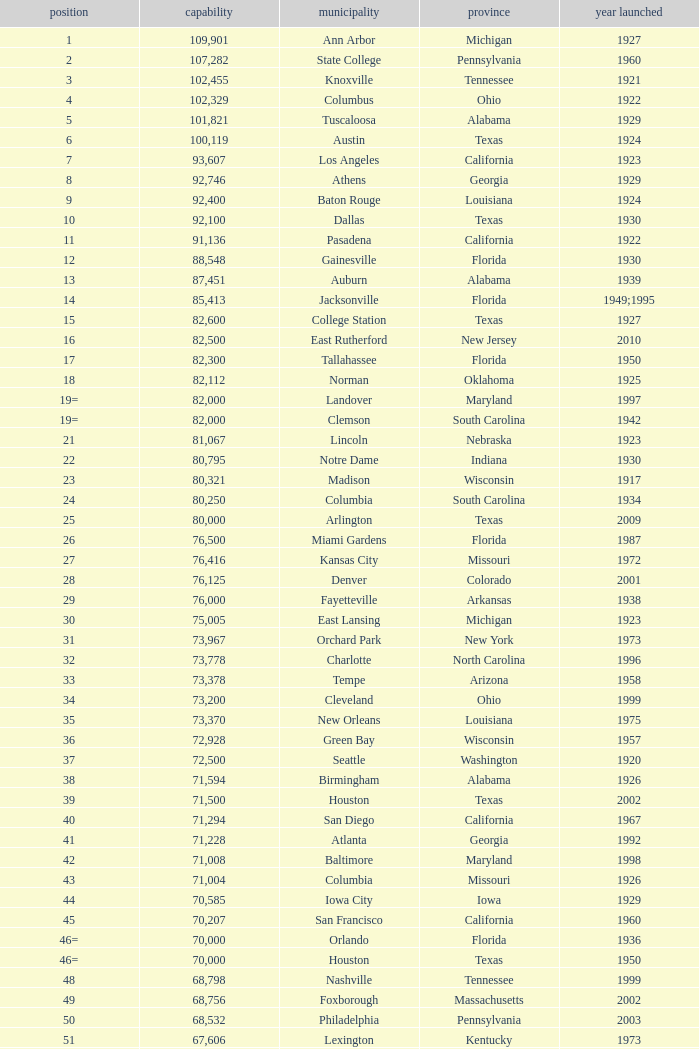What is the city in Alabama that opened in 1996? Huntsville. Could you parse the entire table? {'header': ['position', 'capability', 'municipality', 'province', 'year launched'], 'rows': [['1', '109,901', 'Ann Arbor', 'Michigan', '1927'], ['2', '107,282', 'State College', 'Pennsylvania', '1960'], ['3', '102,455', 'Knoxville', 'Tennessee', '1921'], ['4', '102,329', 'Columbus', 'Ohio', '1922'], ['5', '101,821', 'Tuscaloosa', 'Alabama', '1929'], ['6', '100,119', 'Austin', 'Texas', '1924'], ['7', '93,607', 'Los Angeles', 'California', '1923'], ['8', '92,746', 'Athens', 'Georgia', '1929'], ['9', '92,400', 'Baton Rouge', 'Louisiana', '1924'], ['10', '92,100', 'Dallas', 'Texas', '1930'], ['11', '91,136', 'Pasadena', 'California', '1922'], ['12', '88,548', 'Gainesville', 'Florida', '1930'], ['13', '87,451', 'Auburn', 'Alabama', '1939'], ['14', '85,413', 'Jacksonville', 'Florida', '1949;1995'], ['15', '82,600', 'College Station', 'Texas', '1927'], ['16', '82,500', 'East Rutherford', 'New Jersey', '2010'], ['17', '82,300', 'Tallahassee', 'Florida', '1950'], ['18', '82,112', 'Norman', 'Oklahoma', '1925'], ['19=', '82,000', 'Landover', 'Maryland', '1997'], ['19=', '82,000', 'Clemson', 'South Carolina', '1942'], ['21', '81,067', 'Lincoln', 'Nebraska', '1923'], ['22', '80,795', 'Notre Dame', 'Indiana', '1930'], ['23', '80,321', 'Madison', 'Wisconsin', '1917'], ['24', '80,250', 'Columbia', 'South Carolina', '1934'], ['25', '80,000', 'Arlington', 'Texas', '2009'], ['26', '76,500', 'Miami Gardens', 'Florida', '1987'], ['27', '76,416', 'Kansas City', 'Missouri', '1972'], ['28', '76,125', 'Denver', 'Colorado', '2001'], ['29', '76,000', 'Fayetteville', 'Arkansas', '1938'], ['30', '75,005', 'East Lansing', 'Michigan', '1923'], ['31', '73,967', 'Orchard Park', 'New York', '1973'], ['32', '73,778', 'Charlotte', 'North Carolina', '1996'], ['33', '73,378', 'Tempe', 'Arizona', '1958'], ['34', '73,200', 'Cleveland', 'Ohio', '1999'], ['35', '73,370', 'New Orleans', 'Louisiana', '1975'], ['36', '72,928', 'Green Bay', 'Wisconsin', '1957'], ['37', '72,500', 'Seattle', 'Washington', '1920'], ['38', '71,594', 'Birmingham', 'Alabama', '1926'], ['39', '71,500', 'Houston', 'Texas', '2002'], ['40', '71,294', 'San Diego', 'California', '1967'], ['41', '71,228', 'Atlanta', 'Georgia', '1992'], ['42', '71,008', 'Baltimore', 'Maryland', '1998'], ['43', '71,004', 'Columbia', 'Missouri', '1926'], ['44', '70,585', 'Iowa City', 'Iowa', '1929'], ['45', '70,207', 'San Francisco', 'California', '1960'], ['46=', '70,000', 'Orlando', 'Florida', '1936'], ['46=', '70,000', 'Houston', 'Texas', '1950'], ['48', '68,798', 'Nashville', 'Tennessee', '1999'], ['49', '68,756', 'Foxborough', 'Massachusetts', '2002'], ['50', '68,532', 'Philadelphia', 'Pennsylvania', '2003'], ['51', '67,606', 'Lexington', 'Kentucky', '1973'], ['52', '67,000', 'Seattle', 'Washington', '2002'], ['53', '66,965', 'St. Louis', 'Missouri', '1995'], ['54', '66,233', 'Blacksburg', 'Virginia', '1965'], ['55', '65,857', 'Tampa', 'Florida', '1998'], ['56', '65,790', 'Cincinnati', 'Ohio', '2000'], ['57', '65,050', 'Pittsburgh', 'Pennsylvania', '2001'], ['58=', '65,000', 'San Antonio', 'Texas', '1993'], ['58=', '65,000', 'Detroit', 'Michigan', '2002'], ['60', '64,269', 'New Haven', 'Connecticut', '1914'], ['61', '64,111', 'Minneapolis', 'Minnesota', '1982'], ['62', '64,045', 'Provo', 'Utah', '1964'], ['63', '63,400', 'Glendale', 'Arizona', '2006'], ['64', '63,026', 'Oakland', 'California', '1966'], ['65', '63,000', 'Indianapolis', 'Indiana', '2008'], ['65', '63.000', 'Chapel Hill', 'North Carolina', '1926'], ['66', '62,872', 'Champaign', 'Illinois', '1923'], ['67', '62,717', 'Berkeley', 'California', '1923'], ['68', '61,500', 'Chicago', 'Illinois', '1924;2003'], ['69', '62,500', 'West Lafayette', 'Indiana', '1924'], ['70', '62,380', 'Memphis', 'Tennessee', '1965'], ['71', '61,500', 'Charlottesville', 'Virginia', '1931'], ['72', '61,000', 'Lubbock', 'Texas', '1947'], ['73', '60,580', 'Oxford', 'Mississippi', '1915'], ['74', '60,540', 'Morgantown', 'West Virginia', '1980'], ['75', '60,492', 'Jackson', 'Mississippi', '1941'], ['76', '60,000', 'Stillwater', 'Oklahoma', '1920'], ['78', '57,803', 'Tucson', 'Arizona', '1928'], ['79', '57,583', 'Raleigh', 'North Carolina', '1966'], ['80', '56,692', 'Washington, D.C.', 'District of Columbia', '1961'], ['81=', '56,000', 'Los Angeles', 'California', '1962'], ['81=', '56,000', 'Louisville', 'Kentucky', '1998'], ['83', '55,082', 'Starkville', 'Mississippi', '1914'], ['84=', '55,000', 'Atlanta', 'Georgia', '1913'], ['84=', '55,000', 'Ames', 'Iowa', '1975'], ['86', '53,800', 'Eugene', 'Oregon', '1967'], ['87', '53,750', 'Boulder', 'Colorado', '1924'], ['88', '53,727', 'Little Rock', 'Arkansas', '1948'], ['89', '53,500', 'Bloomington', 'Indiana', '1960'], ['90', '52,593', 'Philadelphia', 'Pennsylvania', '1895'], ['91', '52,480', 'Colorado Springs', 'Colorado', '1962'], ['92', '52,454', 'Piscataway', 'New Jersey', '1994'], ['93', '52,200', 'Manhattan', 'Kansas', '1968'], ['94=', '51,500', 'College Park', 'Maryland', '1950'], ['94=', '51,500', 'El Paso', 'Texas', '1963'], ['96', '50,832', 'Shreveport', 'Louisiana', '1925'], ['97', '50,805', 'Minneapolis', 'Minnesota', '2009'], ['98', '50,445', 'Denver', 'Colorado', '1995'], ['99', '50,291', 'Bronx', 'New York', '2009'], ['100', '50,096', 'Atlanta', 'Georgia', '1996'], ['101', '50,071', 'Lawrence', 'Kansas', '1921'], ['102=', '50,000', 'Honolulu', 'Hawai ʻ i', '1975'], ['102=', '50,000', 'Greenville', 'North Carolina', '1963'], ['102=', '50,000', 'Waco', 'Texas', '1950'], ['102=', '50,000', 'Stanford', 'California', '1921;2006'], ['106', '49,262', 'Syracuse', 'New York', '1980'], ['107', '49,115', 'Arlington', 'Texas', '1994'], ['108', '49,033', 'Phoenix', 'Arizona', '1998'], ['109', '48,876', 'Baltimore', 'Maryland', '1992'], ['110', '47,130', 'Evanston', 'Illinois', '1996'], ['111', '47,116', 'Seattle', 'Washington', '1999'], ['112', '46,861', 'St. Louis', 'Missouri', '2006'], ['113', '45,674', 'Corvallis', 'Oregon', '1953'], ['114', '45,634', 'Salt Lake City', 'Utah', '1998'], ['115', '45,301', 'Orlando', 'Florida', '2007'], ['116', '45,050', 'Anaheim', 'California', '1966'], ['117', '44,500', 'Chestnut Hill', 'Massachusetts', '1957'], ['118', '44,008', 'Fort Worth', 'Texas', '1930'], ['119', '43,647', 'Philadelphia', 'Pennsylvania', '2004'], ['120', '43,545', 'Cleveland', 'Ohio', '1994'], ['121', '42,445', 'San Diego', 'California', '2004'], ['122', '42,059', 'Cincinnati', 'Ohio', '2003'], ['123', '41,900', 'Milwaukee', 'Wisconsin', '2001'], ['124', '41,888', 'Washington, D.C.', 'District of Columbia', '2008'], ['125', '41,800', 'Flushing, New York', 'New York', '2009'], ['126', '41,782', 'Detroit', 'Michigan', '2000'], ['127', '41,503', 'San Francisco', 'California', '2000'], ['128', '41,160', 'Chicago', 'Illinois', '1914'], ['129', '41,031', 'Fresno', 'California', '1980'], ['130', '40,950', 'Houston', 'Texas', '2000'], ['131', '40,646', 'Mobile', 'Alabama', '1948'], ['132', '40,615', 'Chicago', 'Illinois', '1991'], ['133', '40,094', 'Albuquerque', 'New Mexico', '1960'], ['134=', '40,000', 'South Williamsport', 'Pennsylvania', '1959'], ['134=', '40,000', 'East Hartford', 'Connecticut', '2003'], ['134=', '40,000', 'West Point', 'New York', '1924'], ['137', '39,790', 'Nashville', 'Tennessee', '1922'], ['138', '39,504', 'Minneapolis', 'Minnesota', '2010'], ['139', '39,000', 'Kansas City', 'Missouri', '1973'], ['140', '38,496', 'Pittsburgh', 'Pennsylvania', '2001'], ['141', '38,019', 'Huntington', 'West Virginia', '1991'], ['142', '37,402', 'Boston', 'Massachusetts', '1912'], ['143=', '37,000', 'Boise', 'Idaho', '1970'], ['143=', '37,000', 'Miami', 'Florida', '2012'], ['145', '36,973', 'St. Petersburg', 'Florida', '1990'], ['146', '36,800', 'Whitney', 'Nevada', '1971'], ['147', '36,000', 'Hattiesburg', 'Mississippi', '1932'], ['148', '35,117', 'Pullman', 'Washington', '1972'], ['149', '35,097', 'Cincinnati', 'Ohio', '1924'], ['150', '34,400', 'Fort Collins', 'Colorado', '1968'], ['151', '34,000', 'Annapolis', 'Maryland', '1959'], ['152', '33,941', 'Durham', 'North Carolina', '1929'], ['153', '32,580', 'Laramie', 'Wyoming', '1950'], ['154=', '32,000', 'University Park', 'Texas', '2000'], ['154=', '32,000', 'Houston', 'Texas', '1942'], ['156', '31,500', 'Winston-Salem', 'North Carolina', '1968'], ['157=', '31,000', 'Lafayette', 'Louisiana', '1971'], ['157=', '31,000', 'Akron', 'Ohio', '1940'], ['157=', '31,000', 'DeKalb', 'Illinois', '1965'], ['160', '30,964', 'Jonesboro', 'Arkansas', '1974'], ['161', '30,850', 'Denton', 'Texas', '2011'], ['162', '30,600', 'Ruston', 'Louisiana', '1960'], ['163', '30,456', 'San Jose', 'California', '1933'], ['164', '30,427', 'Monroe', 'Louisiana', '1978'], ['165', '30,343', 'Las Cruces', 'New Mexico', '1978'], ['166', '30,323', 'Allston', 'Massachusetts', '1903'], ['167', '30,295', 'Mount Pleasant', 'Michigan', '1972'], ['168=', '30,200', 'Ypsilanti', 'Michigan', '1969'], ['168=', '30,200', 'Kalamazoo', 'Michigan', '1939'], ['168=', '30,000', 'Boca Raton', 'Florida', '2011'], ['168=', '30,000', 'San Marcos', 'Texas', '1981'], ['168=', '30,000', 'Tulsa', 'Oklahoma', '1930'], ['168=', '30,000', 'Akron', 'Ohio', '2009'], ['168=', '30,000', 'Troy', 'Alabama', '1950'], ['168=', '30,000', 'Norfolk', 'Virginia', '1997'], ['176', '29,993', 'Reno', 'Nevada', '1966'], ['177', '29,013', 'Amherst', 'New York', '1993'], ['178', '29,000', 'Baton Rouge', 'Louisiana', '1928'], ['179', '28,646', 'Spokane', 'Washington', '1950'], ['180', '27,800', 'Princeton', 'New Jersey', '1998'], ['181', '27,000', 'Carson', 'California', '2003'], ['182', '26,248', 'Toledo', 'Ohio', '1937'], ['183', '25,600', 'Grambling', 'Louisiana', '1983'], ['184', '25,597', 'Ithaca', 'New York', '1915'], ['185', '25,500', 'Tallahassee', 'Florida', '1957'], ['186', '25,400', 'Muncie', 'Indiana', '1967'], ['187', '25,200', 'Missoula', 'Montana', '1986'], ['188', '25,189', 'Harrison', 'New Jersey', '2010'], ['189', '25,000', 'Kent', 'Ohio', '1969'], ['190', '24,877', 'Harrisonburg', 'Virginia', '1975'], ['191', '24,600', 'Montgomery', 'Alabama', '1922'], ['192', '24,286', 'Oxford', 'Ohio', '1983'], ['193=', '24,000', 'Omaha', 'Nebraska', '2011'], ['193=', '24,000', 'Athens', 'Ohio', '1929'], ['194', '23,724', 'Bowling Green', 'Ohio', '1966'], ['195', '23,500', 'Worcester', 'Massachusetts', '1924'], ['196', '22,500', 'Lorman', 'Mississippi', '1992'], ['197=', '22,000', 'Houston', 'Texas', '2012'], ['197=', '22,000', 'Newark', 'Delaware', '1952'], ['197=', '22,000', 'Bowling Green', 'Kentucky', '1968'], ['197=', '22,000', 'Orangeburg', 'South Carolina', '1955'], ['201', '21,650', 'Boone', 'North Carolina', '1962'], ['202', '21,500', 'Greensboro', 'North Carolina', '1981'], ['203', '21,650', 'Sacramento', 'California', '1969'], ['204=', '21,000', 'Charleston', 'South Carolina', '1946'], ['204=', '21,000', 'Huntsville', 'Alabama', '1996'], ['204=', '21,000', 'Chicago', 'Illinois', '1994'], ['207', '20,668', 'Chattanooga', 'Tennessee', '1997'], ['208', '20,630', 'Youngstown', 'Ohio', '1982'], ['209', '20,500', 'Frisco', 'Texas', '2005'], ['210', '20,455', 'Columbus', 'Ohio', '1999'], ['211', '20,450', 'Fort Lauderdale', 'Florida', '1959'], ['212', '20,438', 'Portland', 'Oregon', '1926'], ['213', '20,311', 'Sacramento, California', 'California', '1928'], ['214', '20,066', 'Detroit, Michigan', 'Michigan', '1979'], ['215', '20,008', 'Sandy', 'Utah', '2008'], ['216=', '20,000', 'Providence', 'Rhode Island', '1925'], ['216=', '20,000', 'Miami', 'Florida', '1995'], ['216=', '20,000', 'Richmond', 'Kentucky', '1969'], ['216=', '20,000', 'Mesquite', 'Texas', '1977'], ['216=', '20,000', 'Canyon', 'Texas', '1959'], ['216=', '20,000', 'Bridgeview', 'Illinois', '2006']]} 